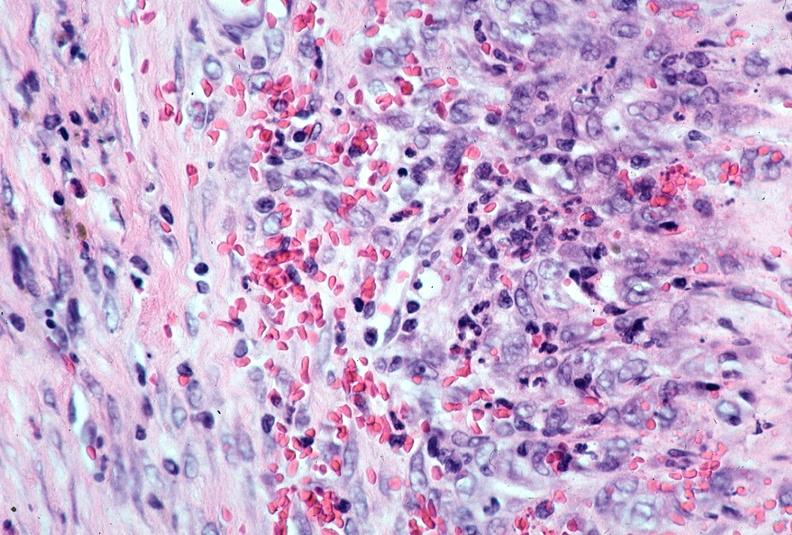s vasculature present?
Answer the question using a single word or phrase. Yes 